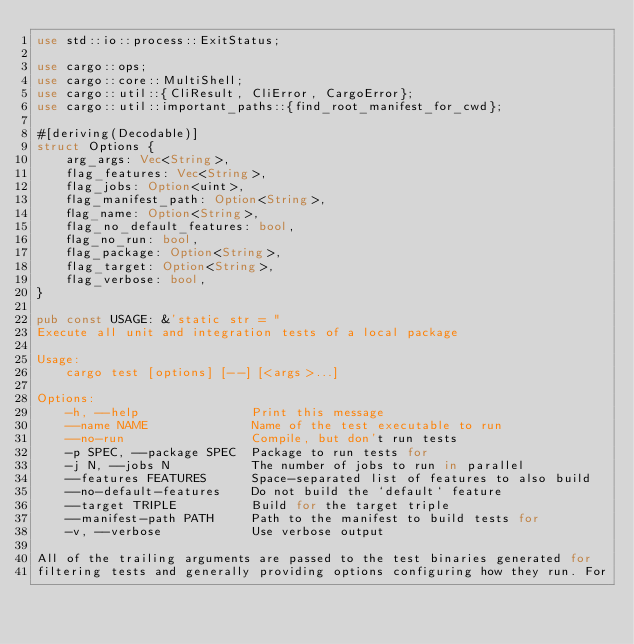<code> <loc_0><loc_0><loc_500><loc_500><_Rust_>use std::io::process::ExitStatus;

use cargo::ops;
use cargo::core::MultiShell;
use cargo::util::{CliResult, CliError, CargoError};
use cargo::util::important_paths::{find_root_manifest_for_cwd};

#[deriving(Decodable)]
struct Options {
    arg_args: Vec<String>,
    flag_features: Vec<String>,
    flag_jobs: Option<uint>,
    flag_manifest_path: Option<String>,
    flag_name: Option<String>,
    flag_no_default_features: bool,
    flag_no_run: bool,
    flag_package: Option<String>,
    flag_target: Option<String>,
    flag_verbose: bool,
}

pub const USAGE: &'static str = "
Execute all unit and integration tests of a local package

Usage:
    cargo test [options] [--] [<args>...]

Options:
    -h, --help               Print this message
    --name NAME              Name of the test executable to run
    --no-run                 Compile, but don't run tests
    -p SPEC, --package SPEC  Package to run tests for
    -j N, --jobs N           The number of jobs to run in parallel
    --features FEATURES      Space-separated list of features to also build
    --no-default-features    Do not build the `default` feature
    --target TRIPLE          Build for the target triple
    --manifest-path PATH     Path to the manifest to build tests for
    -v, --verbose            Use verbose output

All of the trailing arguments are passed to the test binaries generated for
filtering tests and generally providing options configuring how they run. For</code> 